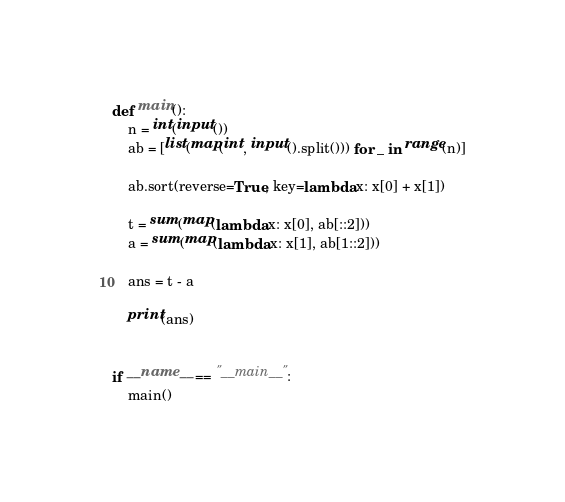Convert code to text. <code><loc_0><loc_0><loc_500><loc_500><_Python_>def main():
    n = int(input())
    ab = [list(map(int, input().split())) for _ in range(n)]

    ab.sort(reverse=True, key=lambda x: x[0] + x[1])

    t = sum(map(lambda x: x[0], ab[::2]))
    a = sum(map(lambda x: x[1], ab[1::2]))

    ans = t - a

    print(ans)


if __name__ == "__main__":
    main()
</code> 